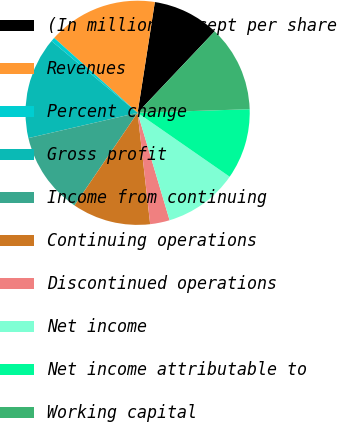<chart> <loc_0><loc_0><loc_500><loc_500><pie_chart><fcel>(In millions except per share<fcel>Revenues<fcel>Percent change<fcel>Gross profit<fcel>Income from continuing<fcel>Continuing operations<fcel>Discontinued operations<fcel>Net income<fcel>Net income attributable to<fcel>Working capital<nl><fcel>9.6%<fcel>15.82%<fcel>0.57%<fcel>14.69%<fcel>11.86%<fcel>11.3%<fcel>2.82%<fcel>10.73%<fcel>10.17%<fcel>12.43%<nl></chart> 